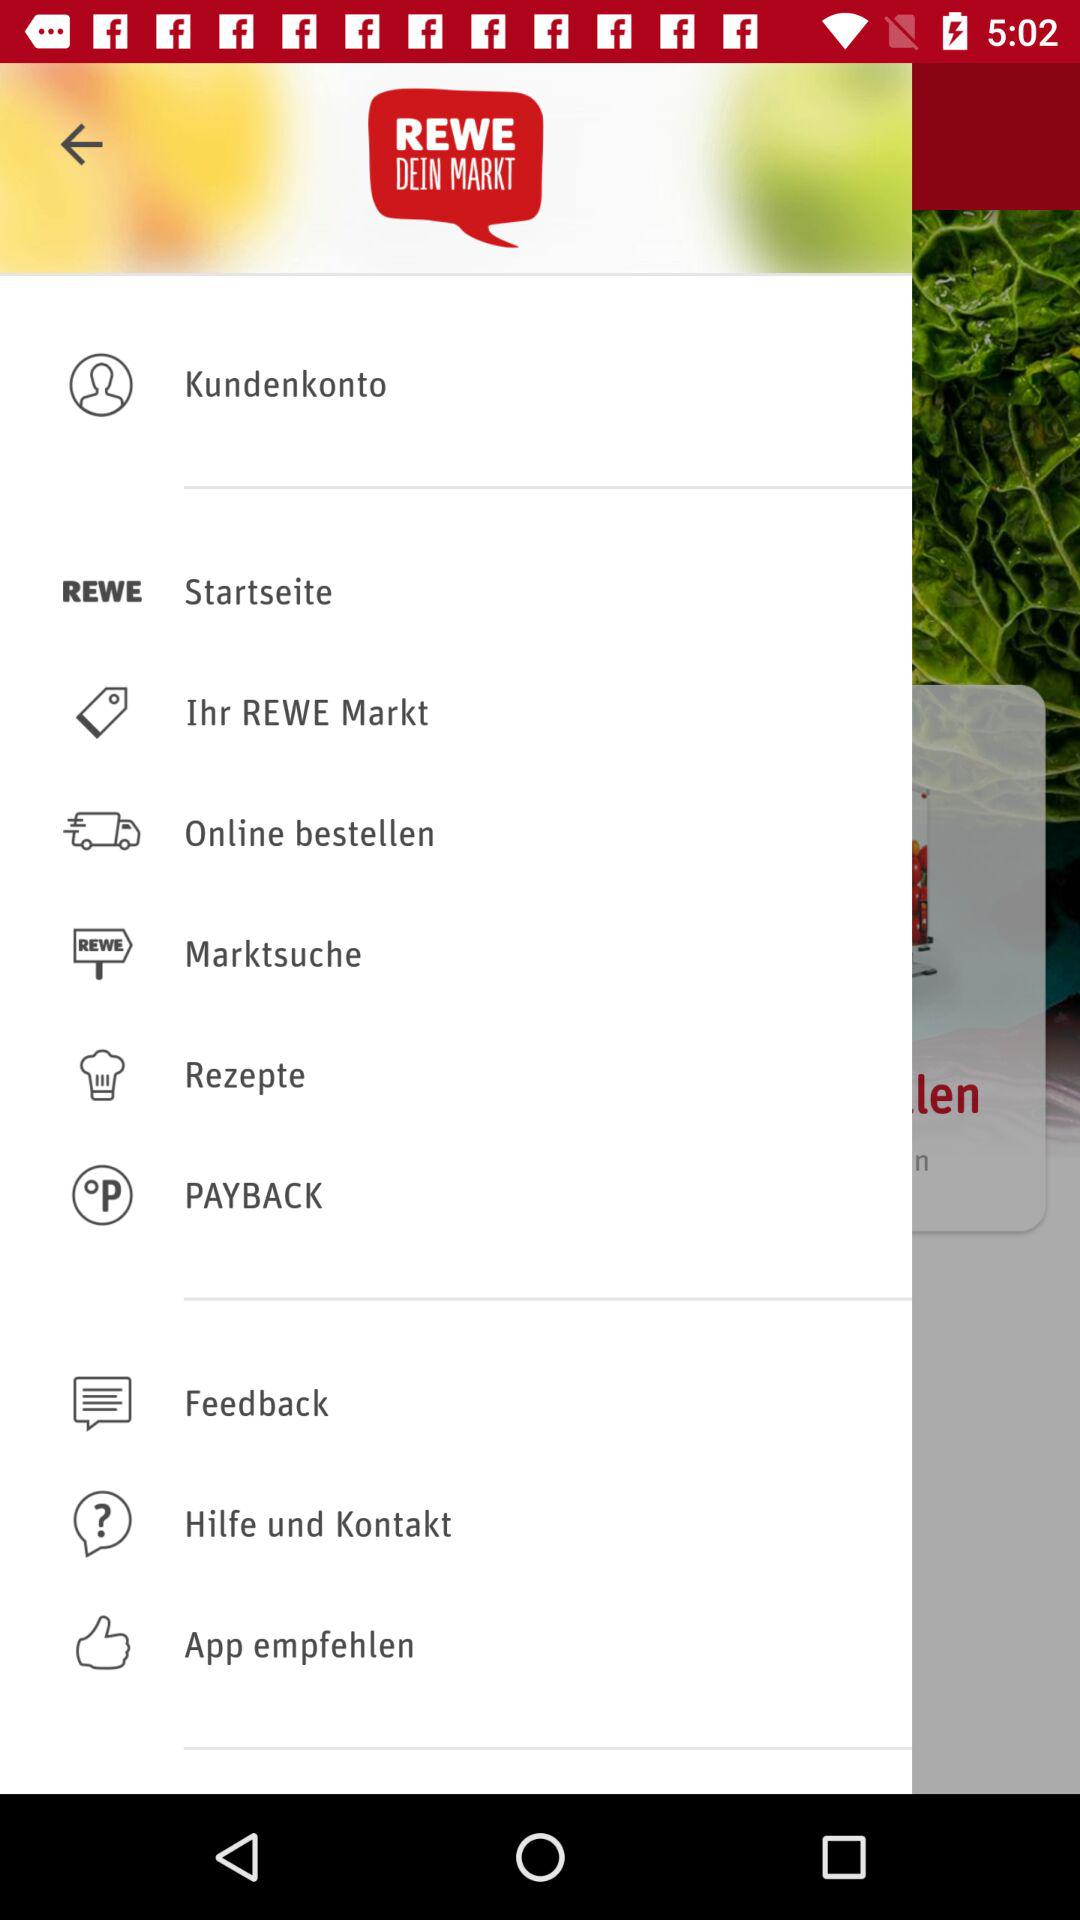What is the name of the application? The name of the application is "REWE DEIN MARKT". 